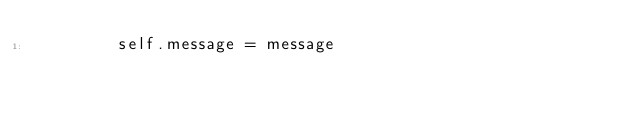<code> <loc_0><loc_0><loc_500><loc_500><_Python_>        self.message = message
</code> 